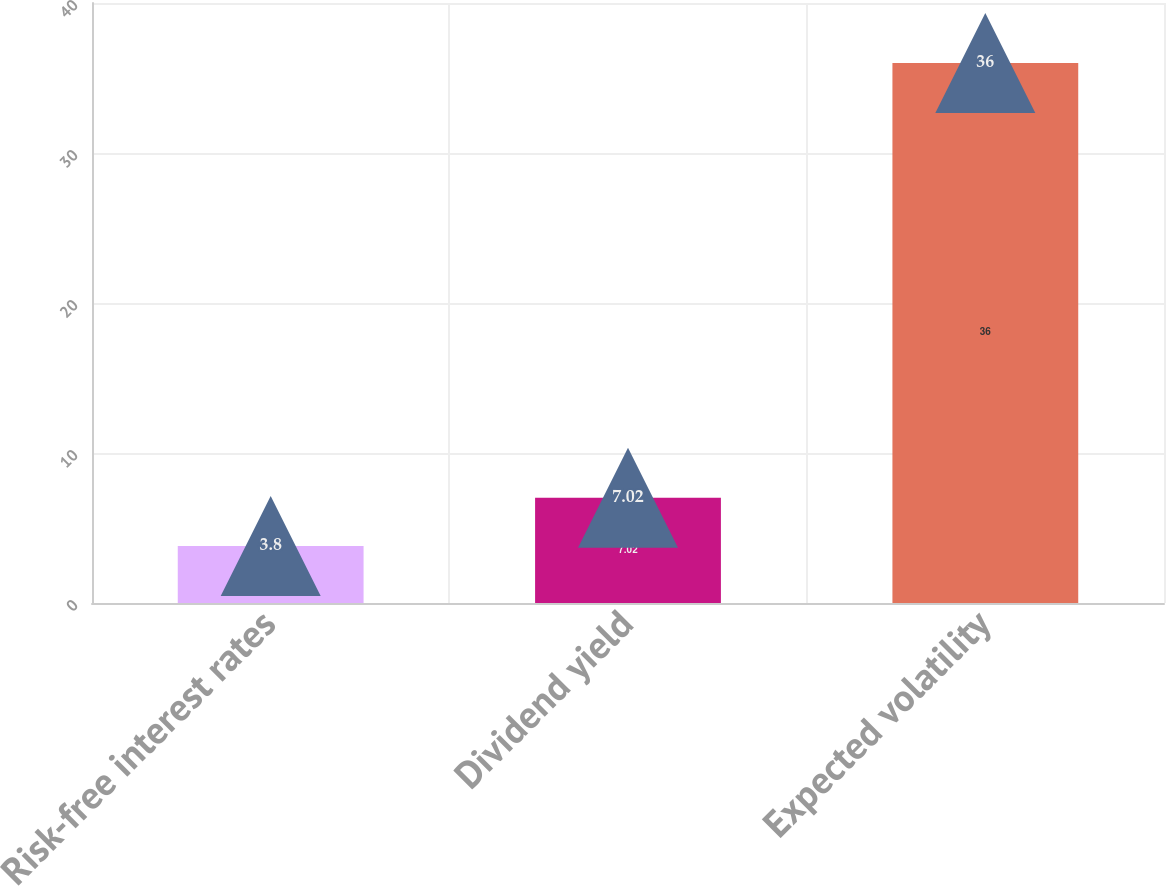<chart> <loc_0><loc_0><loc_500><loc_500><bar_chart><fcel>Risk-free interest rates<fcel>Dividend yield<fcel>Expected volatility<nl><fcel>3.8<fcel>7.02<fcel>36<nl></chart> 